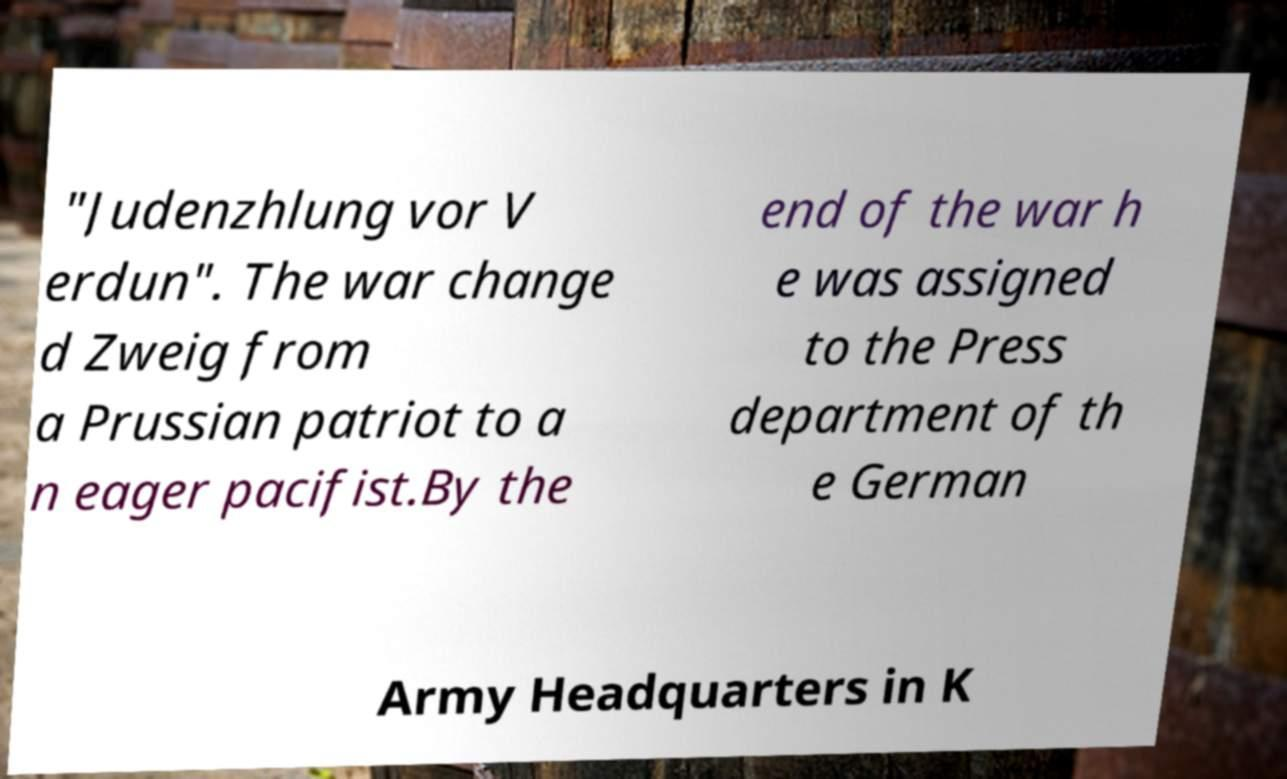Can you read and provide the text displayed in the image?This photo seems to have some interesting text. Can you extract and type it out for me? "Judenzhlung vor V erdun". The war change d Zweig from a Prussian patriot to a n eager pacifist.By the end of the war h e was assigned to the Press department of th e German Army Headquarters in K 